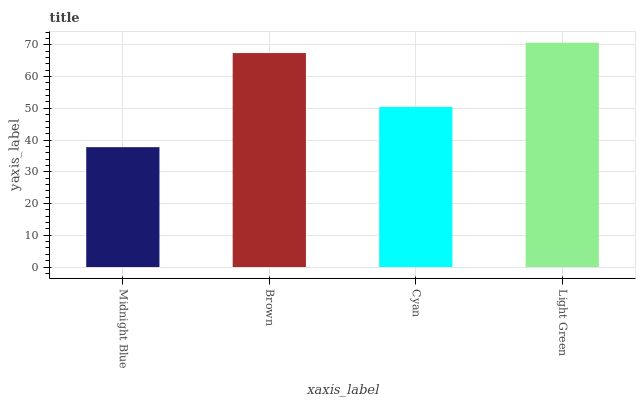Is Midnight Blue the minimum?
Answer yes or no. Yes. Is Light Green the maximum?
Answer yes or no. Yes. Is Brown the minimum?
Answer yes or no. No. Is Brown the maximum?
Answer yes or no. No. Is Brown greater than Midnight Blue?
Answer yes or no. Yes. Is Midnight Blue less than Brown?
Answer yes or no. Yes. Is Midnight Blue greater than Brown?
Answer yes or no. No. Is Brown less than Midnight Blue?
Answer yes or no. No. Is Brown the high median?
Answer yes or no. Yes. Is Cyan the low median?
Answer yes or no. Yes. Is Cyan the high median?
Answer yes or no. No. Is Light Green the low median?
Answer yes or no. No. 